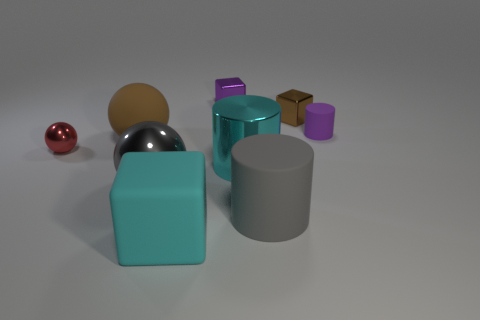Can you tell me what the largest object in the image is? The largest object in the image is the teal blue rectangular prism located in the center. It stands out due to its height and solid color, which contrasts with the other objects. 